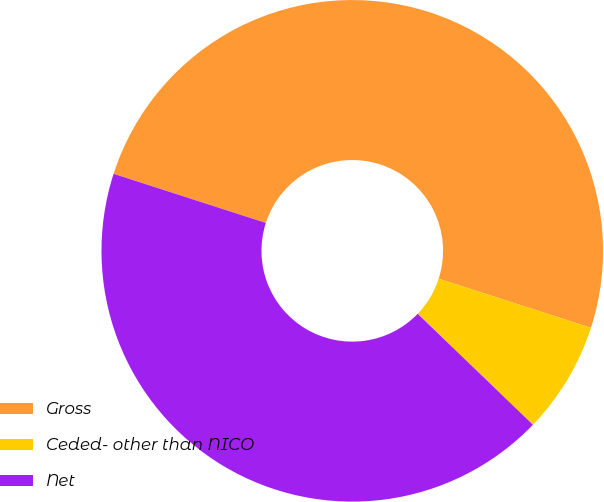Convert chart to OTSL. <chart><loc_0><loc_0><loc_500><loc_500><pie_chart><fcel>Gross<fcel>Ceded- other than NICO<fcel>Net<nl><fcel>50.0%<fcel>7.23%<fcel>42.77%<nl></chart> 